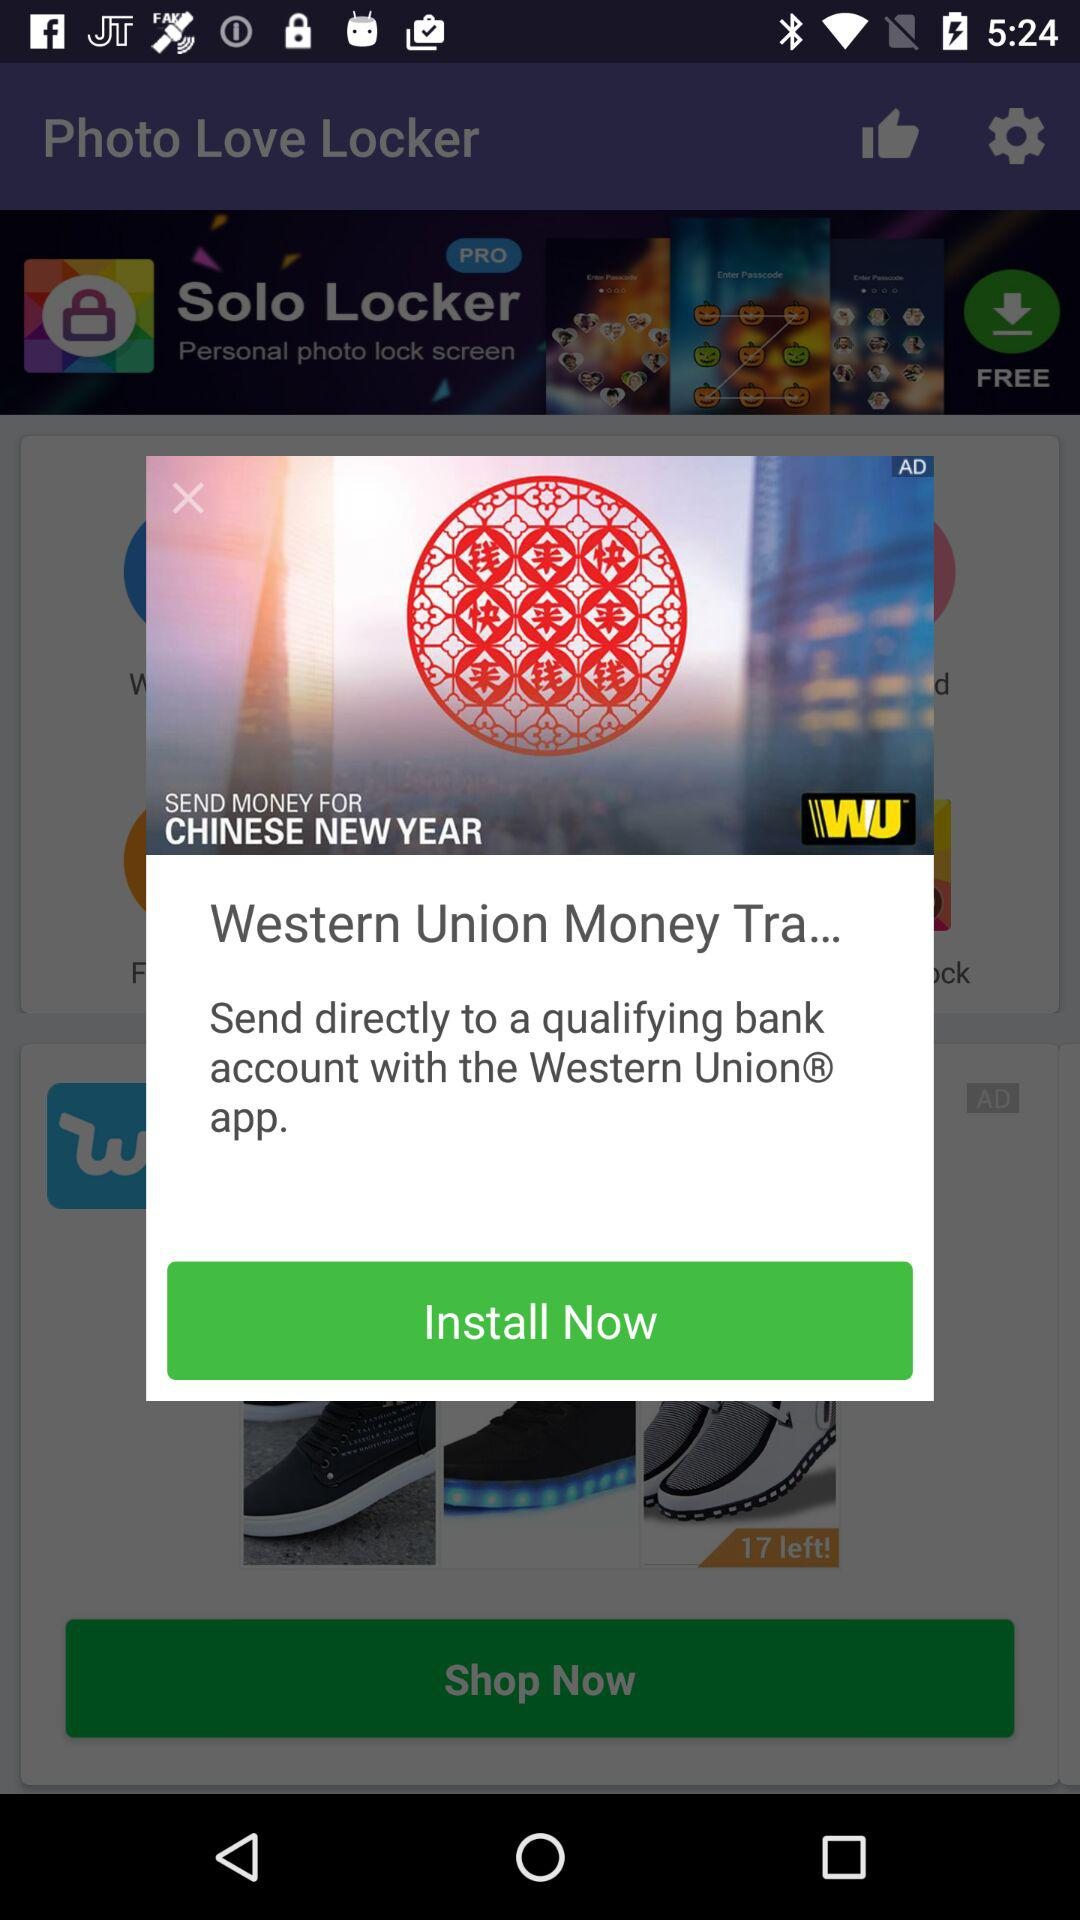How can we send the amount directly to a qualifying bank account? You can send the amount directly to a qualifying bank account with the "Western Union" app. 